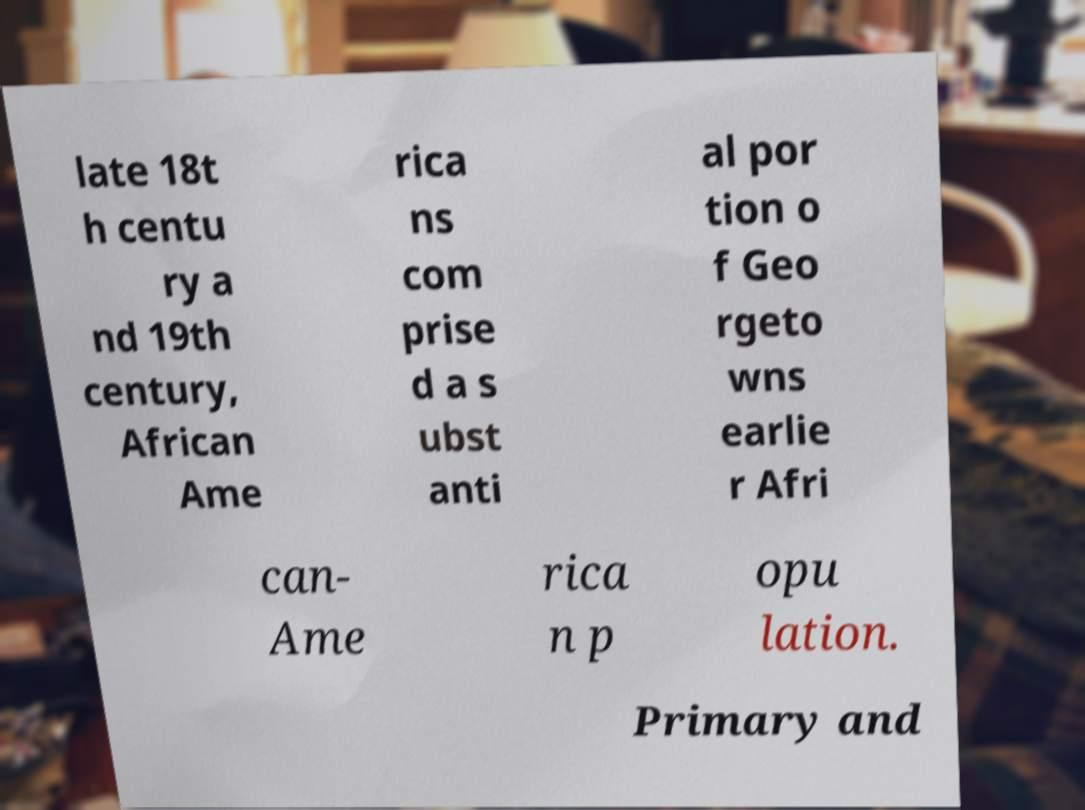There's text embedded in this image that I need extracted. Can you transcribe it verbatim? late 18t h centu ry a nd 19th century, African Ame rica ns com prise d a s ubst anti al por tion o f Geo rgeto wns earlie r Afri can- Ame rica n p opu lation. Primary and 